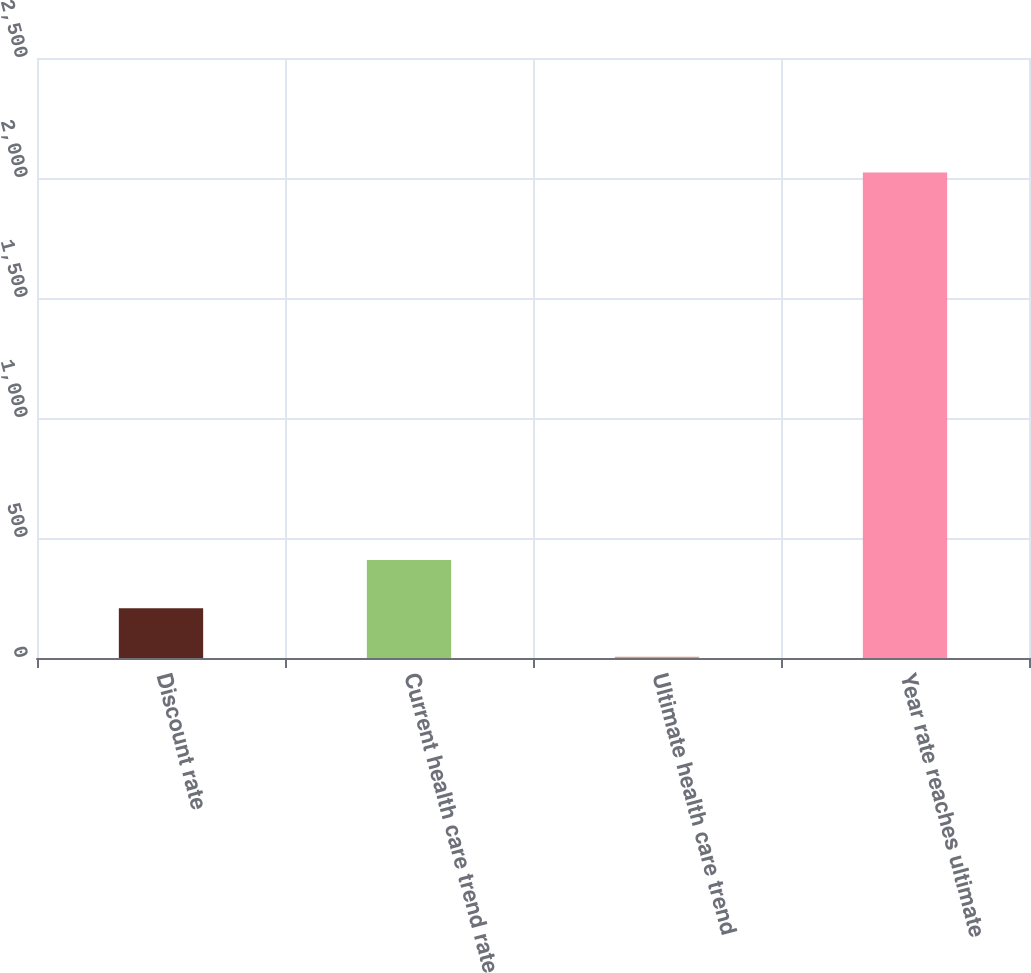<chart> <loc_0><loc_0><loc_500><loc_500><bar_chart><fcel>Discount rate<fcel>Current health care trend rate<fcel>Ultimate health care trend<fcel>Year rate reaches ultimate<nl><fcel>206.8<fcel>408.6<fcel>5<fcel>2023<nl></chart> 